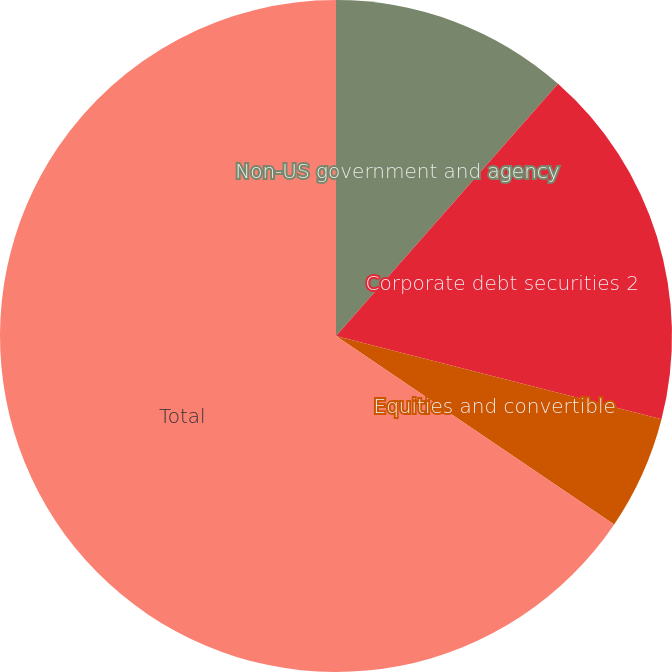Convert chart. <chart><loc_0><loc_0><loc_500><loc_500><pie_chart><fcel>Non-US government and agency<fcel>Corporate debt securities 2<fcel>Equities and convertible<fcel>Total<nl><fcel>11.49%<fcel>17.5%<fcel>5.49%<fcel>65.53%<nl></chart> 